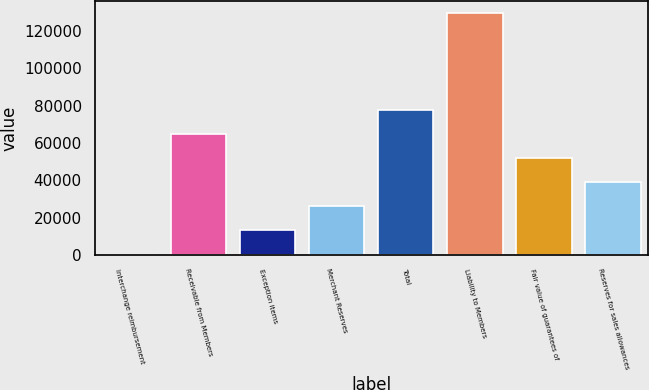<chart> <loc_0><loc_0><loc_500><loc_500><bar_chart><fcel>Interchange reimbursement<fcel>Receivable from Members<fcel>Exception items<fcel>Merchant Reserves<fcel>Total<fcel>Liability to Members<fcel>Fair value of guarantees of<fcel>Reserves for sales allowances<nl><fcel>222<fcel>64758.5<fcel>13129.3<fcel>26036.6<fcel>77665.8<fcel>129295<fcel>51851.2<fcel>38943.9<nl></chart> 